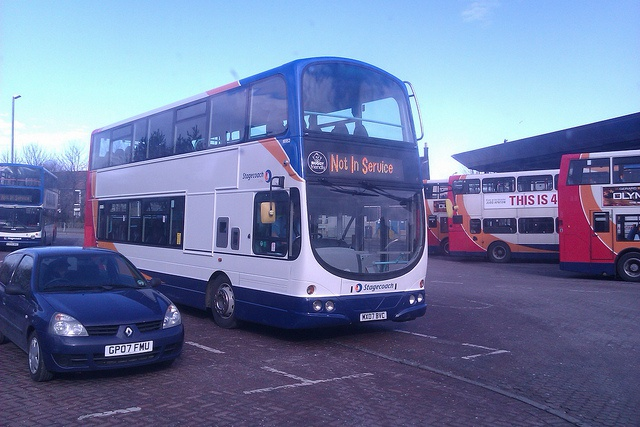Describe the objects in this image and their specific colors. I can see bus in lightblue, blue, darkgray, navy, and lavender tones, car in lightblue, navy, black, blue, and gray tones, bus in lightblue, purple, navy, black, and brown tones, bus in lightblue, navy, lavender, blue, and gray tones, and bus in lightblue, blue, navy, and darkblue tones in this image. 